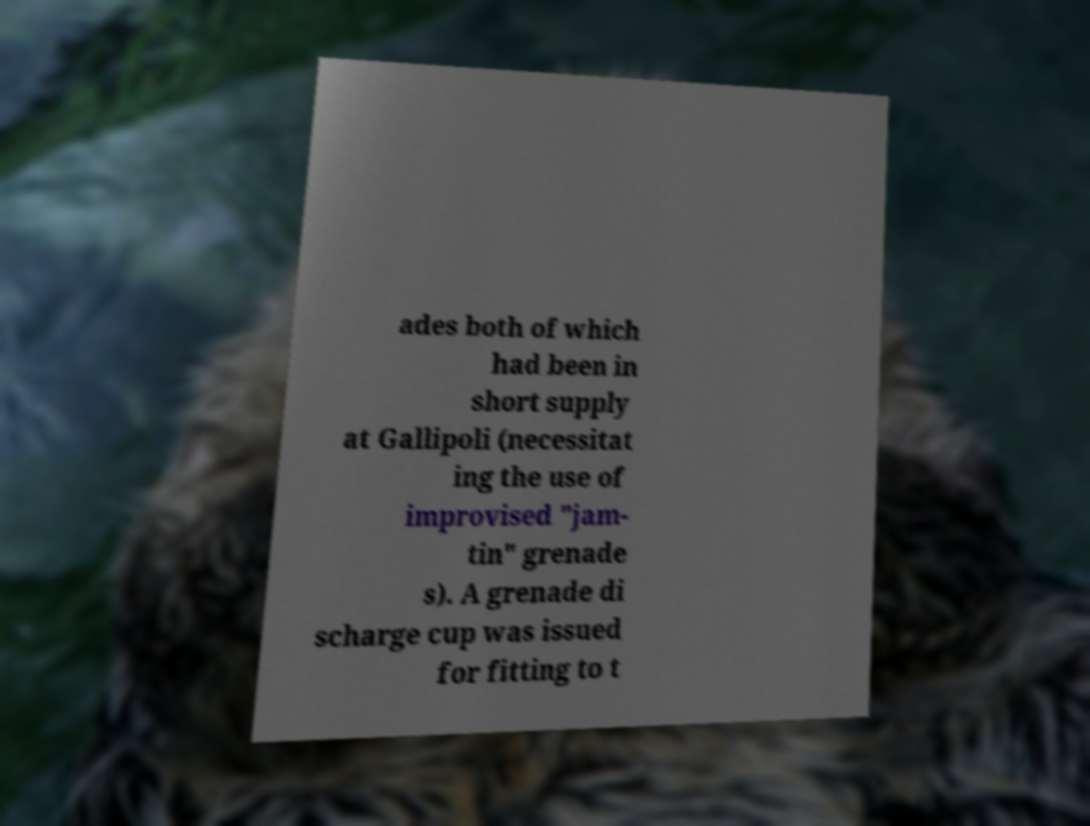I need the written content from this picture converted into text. Can you do that? ades both of which had been in short supply at Gallipoli (necessitat ing the use of improvised "jam- tin" grenade s). A grenade di scharge cup was issued for fitting to t 